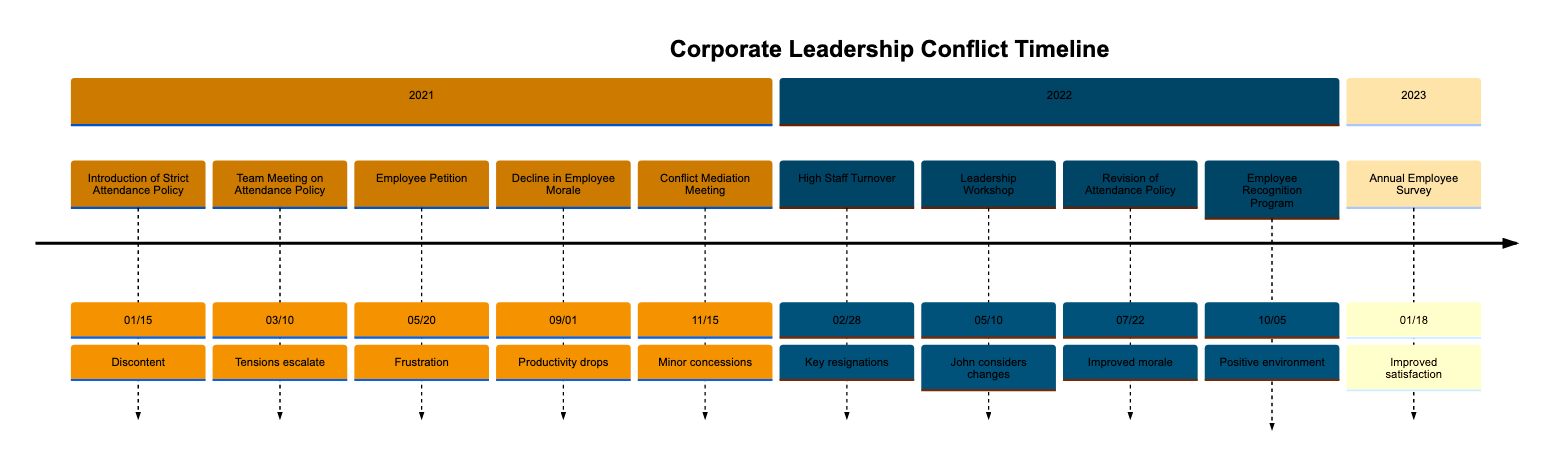What event was introduced on January 15, 2021? The timeline shows that on January 15, 2021, the event "Introduction of Strict Attendance Policy" was introduced. This information can be found directly at the specified date in the diagram.
Answer: Introduction of Strict Attendance Policy How many major conflict events occurred in 2021? By counting the events listed under the year 2021, we find five major conflict events: "Introduction of Strict Attendance Policy," "Team Meeting on Attendance Policy," "Employee Petition," "Decline in Employee Morale," and "Conflict Mediation Meeting." Therefore, the total is five.
Answer: 5 What was the outcome of the conflict mediation meeting on November 15, 2021? The conflict mediation meeting on November 15, 2021, led to "minor concessions" by John Smith, indicating that some agreement was reached, albeit without significant changes to his leadership style.
Answer: Minor concessions When did the Leadership Workshop take place? The Leadership Workshop took place on May 10, 2022, as specifically indicated in the timeline. This date item is clearly marked, making it straightforward to locate.
Answer: May 10, 2022 What was reported on September 1, 2021, regarding employee morale? On September 1, 2021, the event noted a "Decline in Employee Morale," with HR reporting significant drops in morale and productivity, directly indicating the impact of strict policies.
Answer: Decline in Employee Morale Which event led to improvements in morale according to the timeline? The "Revision of Attendance Policy" announced on July 22, 2022, led to improved morale, as it followed consultations with employees and showed a shift in management approach.
Answer: Revision of Attendance Policy What was the overall trend shown by the Annual Employee Survey conducted on January 18, 2023? The Annual Employee Survey conducted on January 18, 2023, indicated "significant improvements in job satisfaction and morale," marking a positive trend resulting from the changes implemented by John Smith.
Answer: Significant improvements How many events are listed in the year 2022? In the year 2022, there are four events listed: "High Staff Turnover," "Leadership Workshop," "Revision of Attendance Policy," and "Employee Recognition Program." When counting these, we find that the total is four.
Answer: 4 